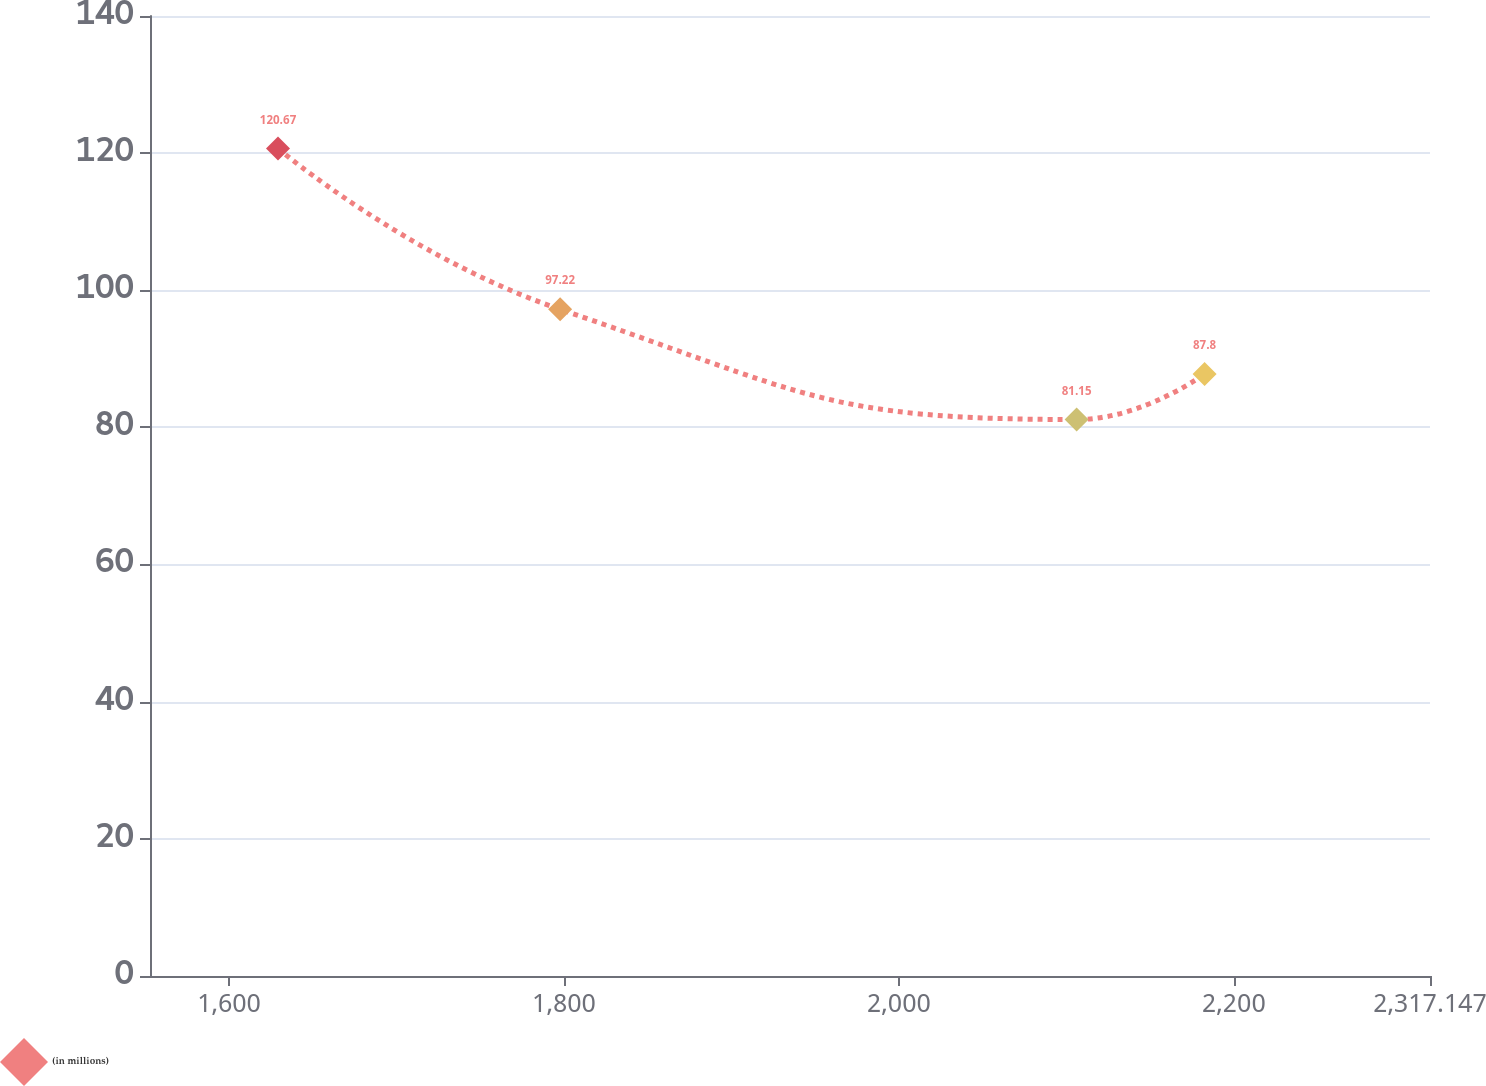Convert chart to OTSL. <chart><loc_0><loc_0><loc_500><loc_500><line_chart><ecel><fcel>(in millions)<nl><fcel>1629.25<fcel>120.67<nl><fcel>1797.71<fcel>97.22<nl><fcel>2106.12<fcel>81.15<nl><fcel>2182.55<fcel>87.8<nl><fcel>2393.58<fcel>54.17<nl></chart> 